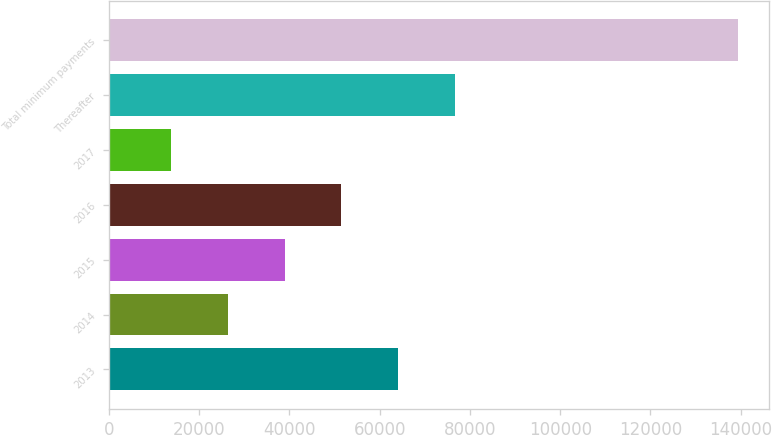Convert chart. <chart><loc_0><loc_0><loc_500><loc_500><bar_chart><fcel>2013<fcel>2014<fcel>2015<fcel>2016<fcel>2017<fcel>Thereafter<fcel>Total minimum payments<nl><fcel>64046.6<fcel>26390.9<fcel>38942.8<fcel>51494.7<fcel>13839<fcel>76598.5<fcel>139358<nl></chart> 